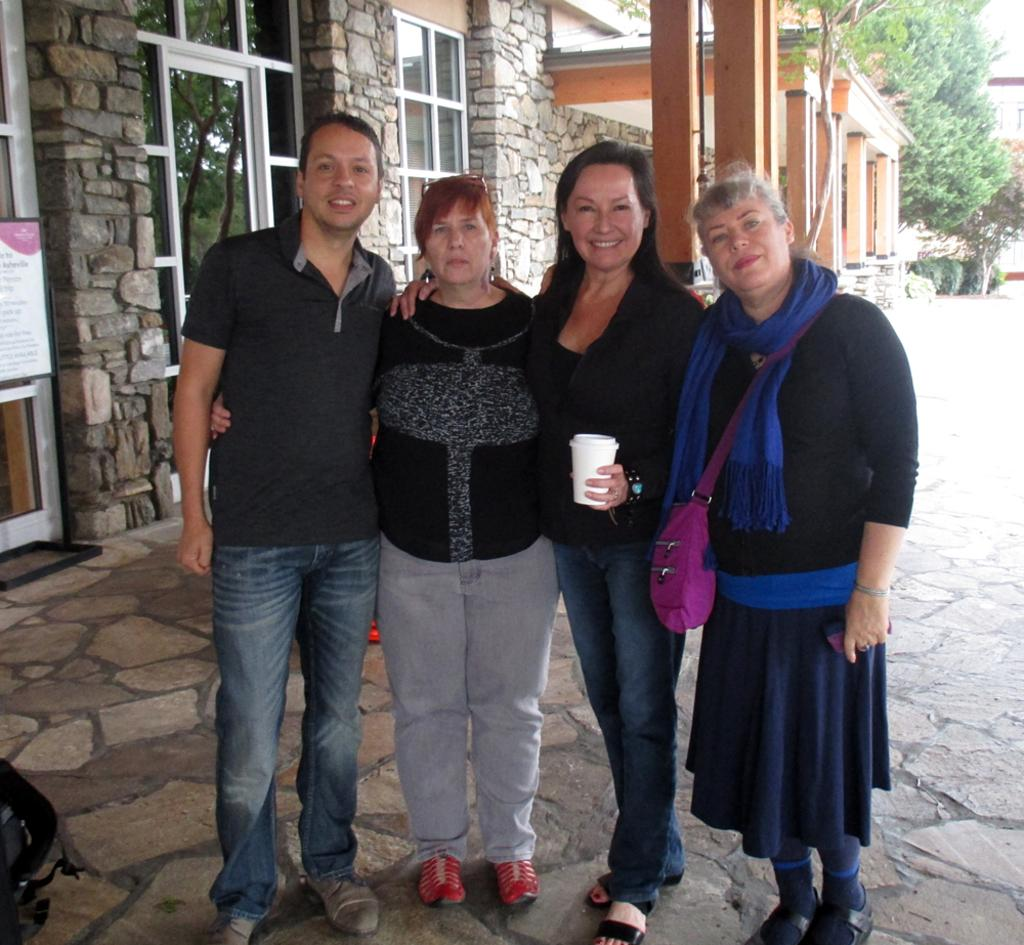How many people are in the image? There is a group of people in the image, but the exact number is not specified. What is the position of the people in the image? The people are standing on the ground in the image. What can be seen in the background of the image? There are buildings and trees in the background of the image. What type of calculator is being used by the person in the image? There is no calculator present in the image. How many heads are visible in the image? The number of heads visible in the image is not specified, but there is a group of people present. 